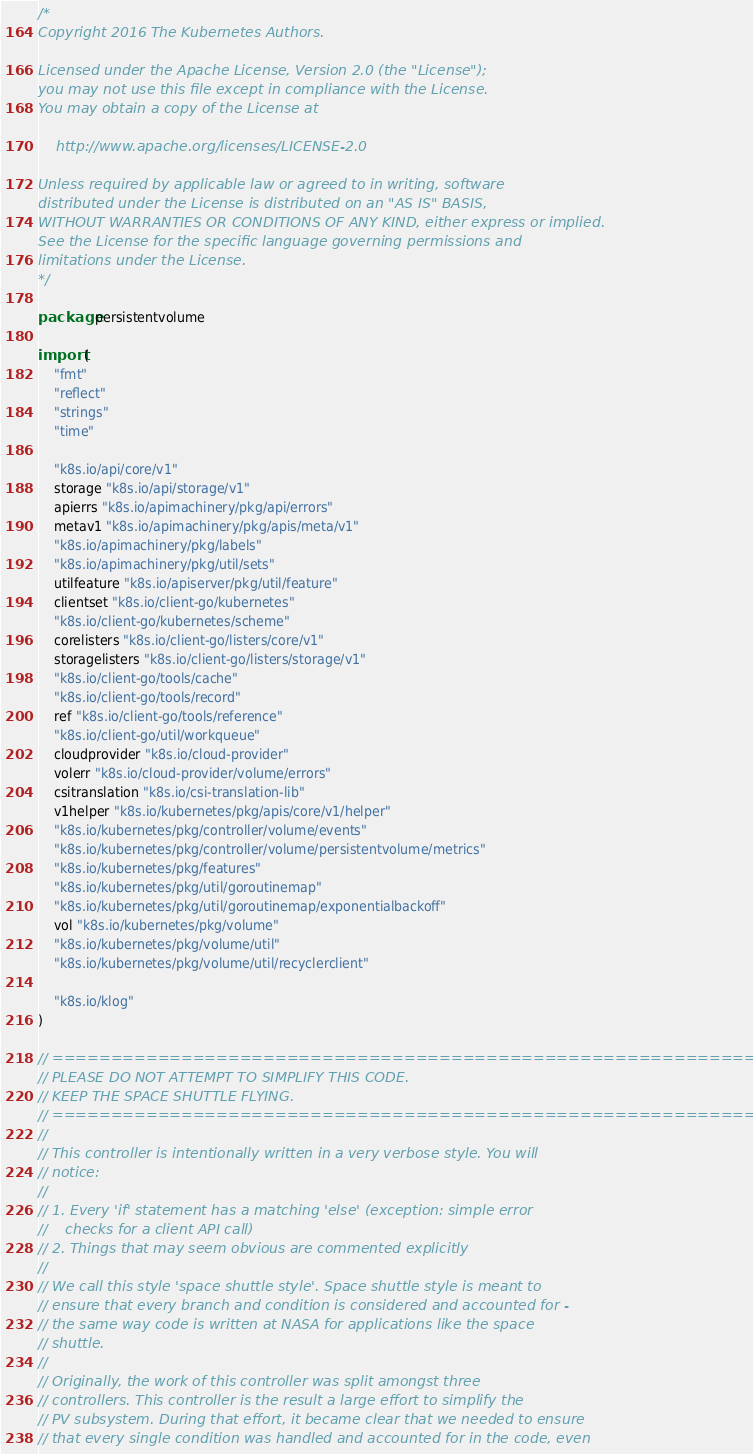Convert code to text. <code><loc_0><loc_0><loc_500><loc_500><_Go_>/*
Copyright 2016 The Kubernetes Authors.

Licensed under the Apache License, Version 2.0 (the "License");
you may not use this file except in compliance with the License.
You may obtain a copy of the License at

    http://www.apache.org/licenses/LICENSE-2.0

Unless required by applicable law or agreed to in writing, software
distributed under the License is distributed on an "AS IS" BASIS,
WITHOUT WARRANTIES OR CONDITIONS OF ANY KIND, either express or implied.
See the License for the specific language governing permissions and
limitations under the License.
*/

package persistentvolume

import (
	"fmt"
	"reflect"
	"strings"
	"time"

	"k8s.io/api/core/v1"
	storage "k8s.io/api/storage/v1"
	apierrs "k8s.io/apimachinery/pkg/api/errors"
	metav1 "k8s.io/apimachinery/pkg/apis/meta/v1"
	"k8s.io/apimachinery/pkg/labels"
	"k8s.io/apimachinery/pkg/util/sets"
	utilfeature "k8s.io/apiserver/pkg/util/feature"
	clientset "k8s.io/client-go/kubernetes"
	"k8s.io/client-go/kubernetes/scheme"
	corelisters "k8s.io/client-go/listers/core/v1"
	storagelisters "k8s.io/client-go/listers/storage/v1"
	"k8s.io/client-go/tools/cache"
	"k8s.io/client-go/tools/record"
	ref "k8s.io/client-go/tools/reference"
	"k8s.io/client-go/util/workqueue"
	cloudprovider "k8s.io/cloud-provider"
	volerr "k8s.io/cloud-provider/volume/errors"
	csitranslation "k8s.io/csi-translation-lib"
	v1helper "k8s.io/kubernetes/pkg/apis/core/v1/helper"
	"k8s.io/kubernetes/pkg/controller/volume/events"
	"k8s.io/kubernetes/pkg/controller/volume/persistentvolume/metrics"
	"k8s.io/kubernetes/pkg/features"
	"k8s.io/kubernetes/pkg/util/goroutinemap"
	"k8s.io/kubernetes/pkg/util/goroutinemap/exponentialbackoff"
	vol "k8s.io/kubernetes/pkg/volume"
	"k8s.io/kubernetes/pkg/volume/util"
	"k8s.io/kubernetes/pkg/volume/util/recyclerclient"

	"k8s.io/klog"
)

// ==================================================================
// PLEASE DO NOT ATTEMPT TO SIMPLIFY THIS CODE.
// KEEP THE SPACE SHUTTLE FLYING.
// ==================================================================
//
// This controller is intentionally written in a very verbose style. You will
// notice:
//
// 1. Every 'if' statement has a matching 'else' (exception: simple error
//    checks for a client API call)
// 2. Things that may seem obvious are commented explicitly
//
// We call this style 'space shuttle style'. Space shuttle style is meant to
// ensure that every branch and condition is considered and accounted for -
// the same way code is written at NASA for applications like the space
// shuttle.
//
// Originally, the work of this controller was split amongst three
// controllers. This controller is the result a large effort to simplify the
// PV subsystem. During that effort, it became clear that we needed to ensure
// that every single condition was handled and accounted for in the code, even</code> 